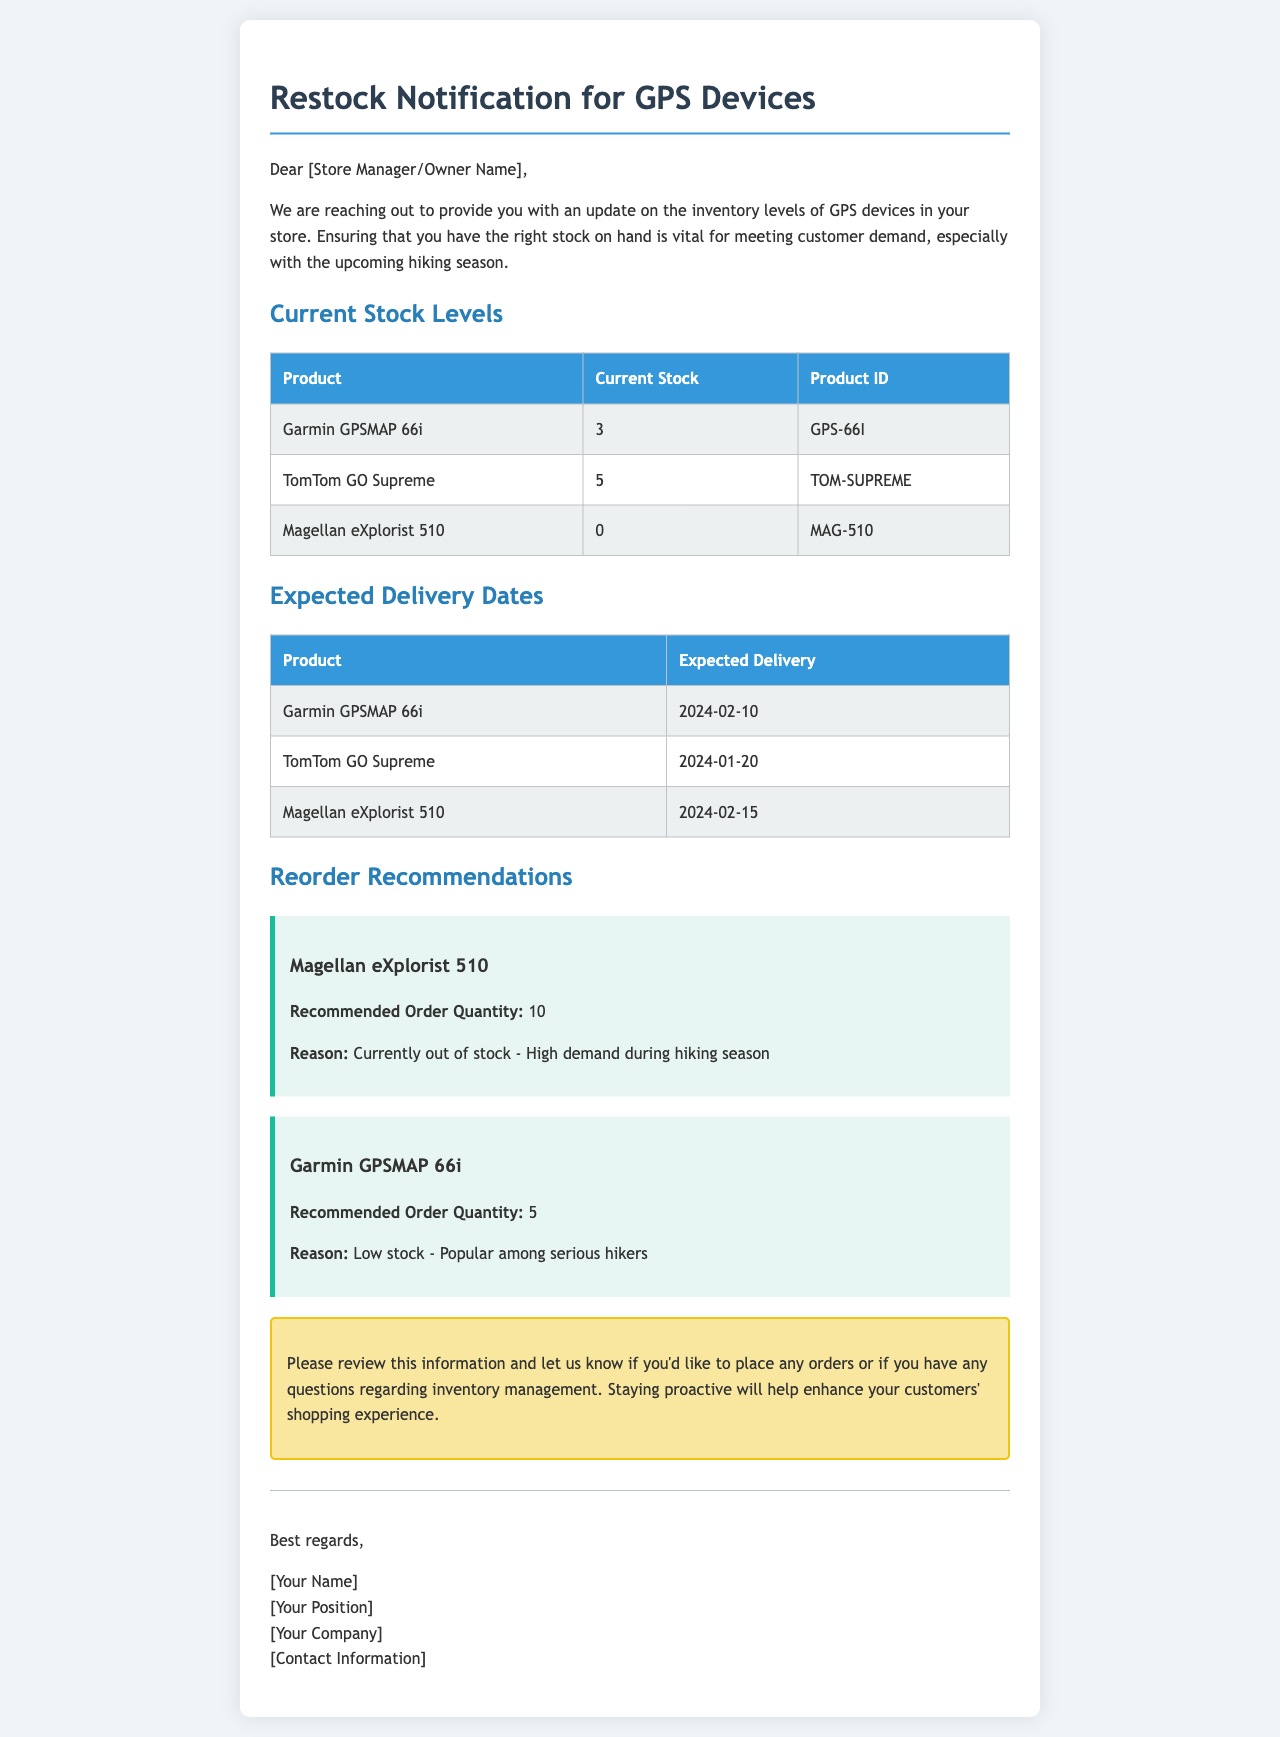What is the current stock of Garmin GPSMAP 66i? The current stock of Garmin GPSMAP 66i is listed in the inventory levels section.
Answer: 3 When is the expected delivery date for TomTom GO Supreme? The expected delivery date for TomTom GO Supreme is found in the expected delivery dates section.
Answer: 2024-01-20 What is the recommended order quantity for Magellan eXplorist 510? The recommended order quantity for Magellan eXplorist 510 is stated in the reorder recommendations section.
Answer: 10 Why is there a recommendation for Garmin GPSMAP 66i? The reason for the recommendation is mentioned in the reorder recommendations section regarding its stock level.
Answer: Low stock - Popular among serious hikers What is the primary purpose of this email? The purpose is stated at the beginning of the email, focusing on inventory updates.
Answer: Inventory levels update 